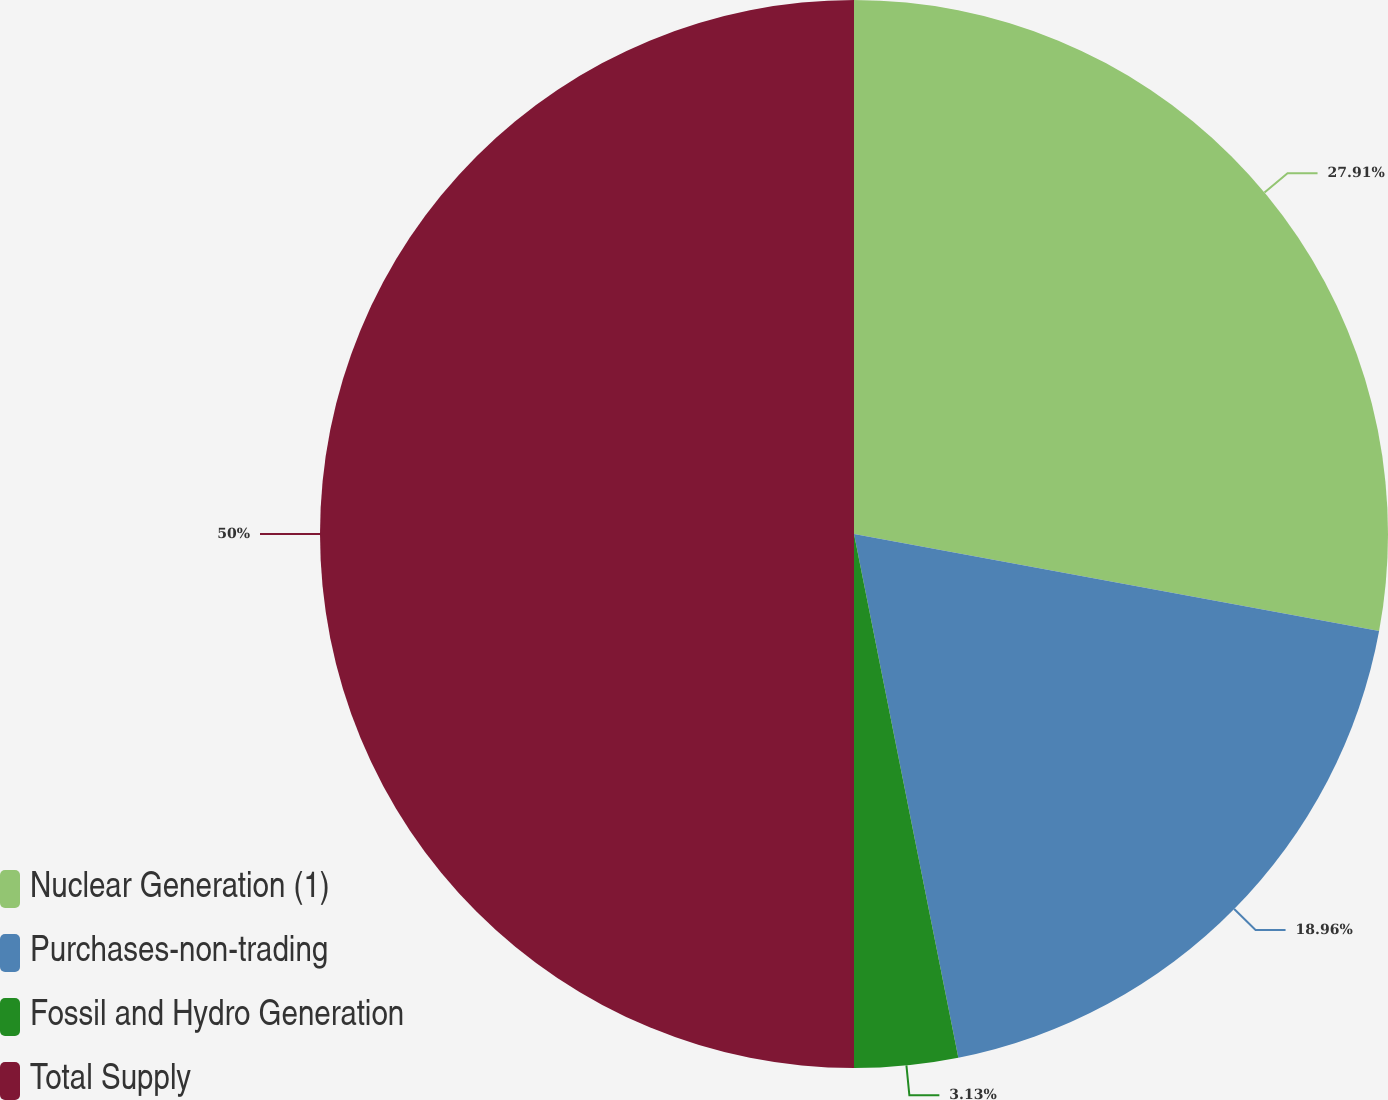Convert chart to OTSL. <chart><loc_0><loc_0><loc_500><loc_500><pie_chart><fcel>Nuclear Generation (1)<fcel>Purchases-non-trading<fcel>Fossil and Hydro Generation<fcel>Total Supply<nl><fcel>27.91%<fcel>18.96%<fcel>3.13%<fcel>50.0%<nl></chart> 